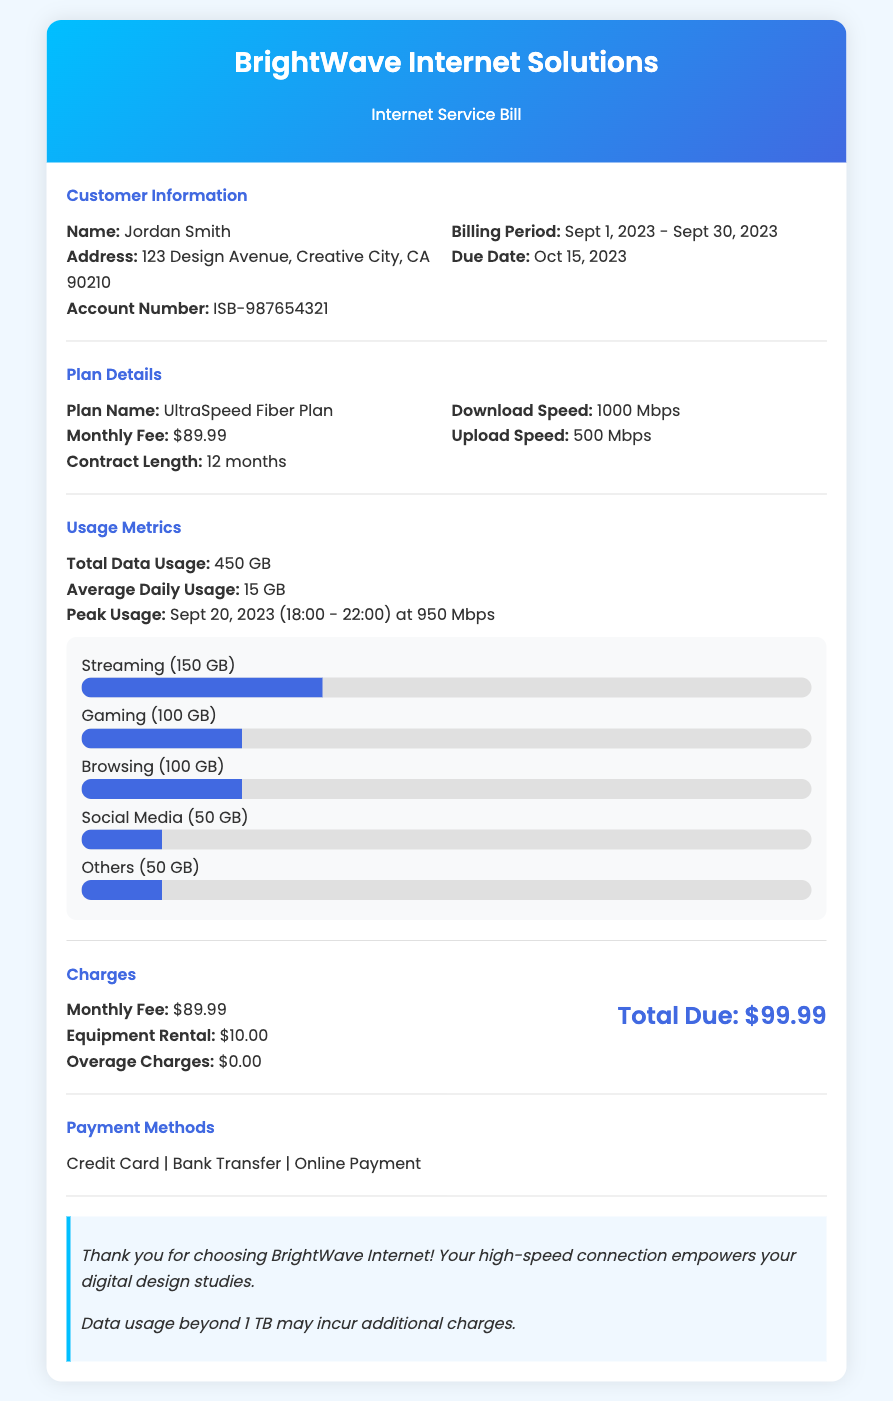What is the customer's name? The customer's name is found in the customer information section.
Answer: Jordan Smith What is the billing period? The billing period is specified in the customer information section of the bill.
Answer: Sept 1, 2023 - Sept 30, 2023 What is the average daily usage? The average daily usage is mentioned in the usage metrics section.
Answer: 15 GB What is the download speed of the plan? The download speed is detailed in the plan details section of the document.
Answer: 1000 Mbps What was the peak usage date? The peak usage date is specified in the usage metrics section of the bill.
Answer: Sept 20, 2023 What is the total due amount? The total due amount is calculated and presented in the charges section.
Answer: $99.99 How much is the equipment rental fee? The equipment rental fee is listed under the charges section.
Answer: $10.00 Which plan is being used by the customer? The plan used by the customer is stated in the plan details section.
Answer: UltraSpeed Fiber Plan 